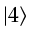Convert formula to latex. <formula><loc_0><loc_0><loc_500><loc_500>| 4 \rangle</formula> 